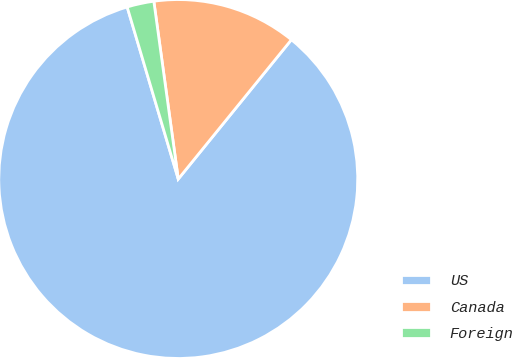Convert chart to OTSL. <chart><loc_0><loc_0><loc_500><loc_500><pie_chart><fcel>US<fcel>Canada<fcel>Foreign<nl><fcel>84.55%<fcel>13.03%<fcel>2.42%<nl></chart> 